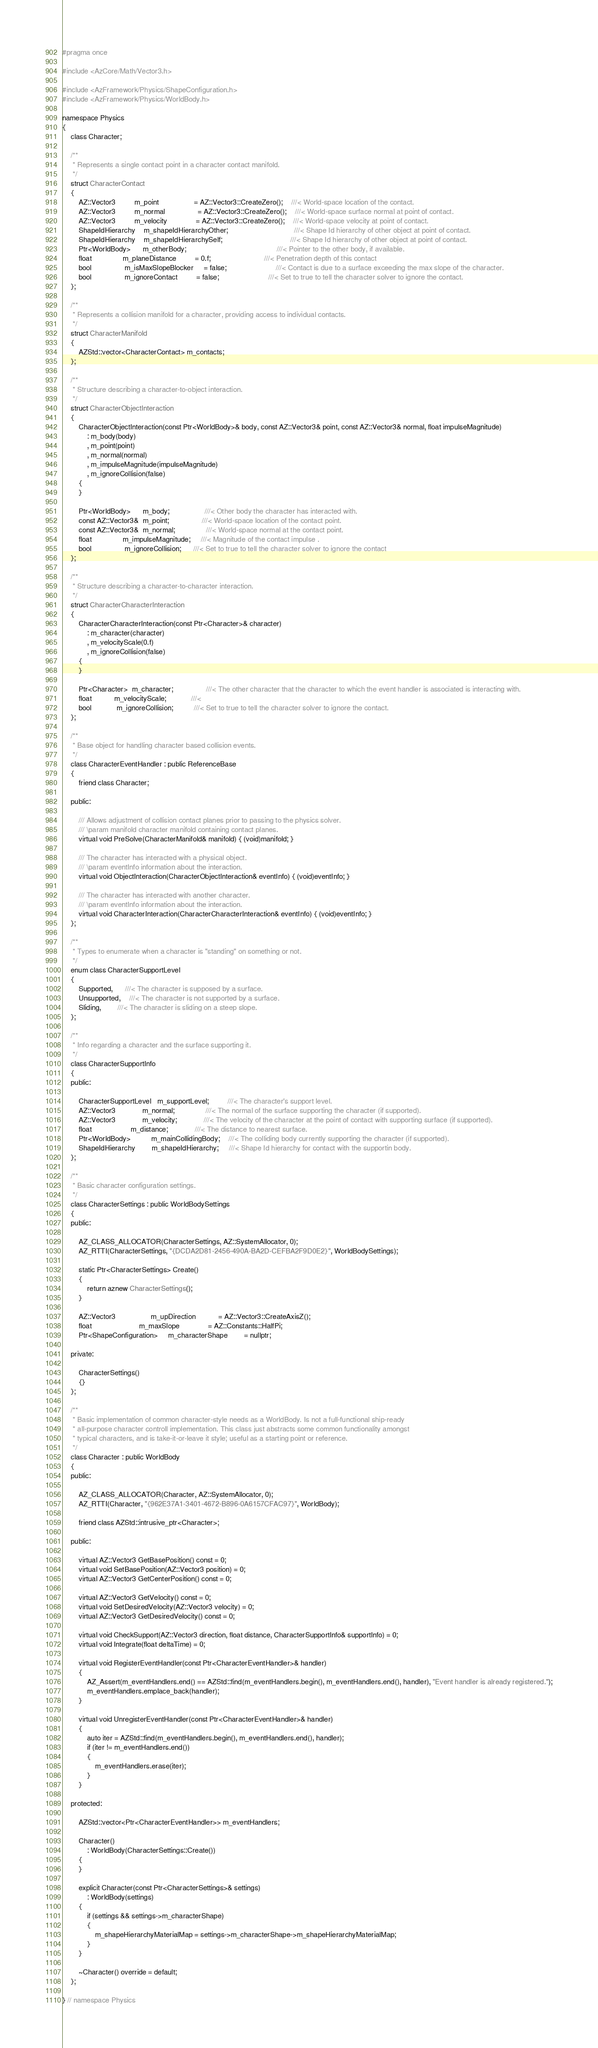<code> <loc_0><loc_0><loc_500><loc_500><_C_>
#pragma once

#include <AzCore/Math/Vector3.h>

#include <AzFramework/Physics/ShapeConfiguration.h>
#include <AzFramework/Physics/WorldBody.h>

namespace Physics
{
    class Character;

    /**
     * Represents a single contact point in a character contact manifold.
     */
    struct CharacterContact
    {
        AZ::Vector3         m_point                 = AZ::Vector3::CreateZero();    ///< World-space location of the contact.
        AZ::Vector3         m_normal                = AZ::Vector3::CreateZero();    ///< World-space surface normal at point of contact.
        AZ::Vector3         m_velocity              = AZ::Vector3::CreateZero();    ///< World-space velocity at point of contact.
        ShapeIdHierarchy    m_shapeIdHierarchyOther;                                ///< Shape Id hierarchy of other object at point of contact.
        ShapeIdHierarchy    m_shapeIdHierarchySelf;                                 ///< Shape Id hierarchy of other object at point of contact.
        Ptr<WorldBody>      m_otherBody;                                            ///< Pointer to the other body, if available.
        float               m_planeDistance         = 0.f;                          ///< Penetration depth of this contact
        bool                m_isMaxSlopeBlocker     = false;                        ///< Contact is due to a surface exceeding the max slope of the character.
        bool                m_ignoreContact         = false;                        ///< Set to true to tell the character solver to ignore the contact.
    };

    /**
     * Represents a collision manifold for a character, providing access to individual contacts.
     */
    struct CharacterManifold
    {
        AZStd::vector<CharacterContact> m_contacts;
    };

    /**
     * Structure describing a character-to-object interaction.
     */
    struct CharacterObjectInteraction
    {
        CharacterObjectInteraction(const Ptr<WorldBody>& body, const AZ::Vector3& point, const AZ::Vector3& normal, float impulseMagnitude)
            : m_body(body)
            , m_point(point)
            , m_normal(normal)
            , m_impulseMagnitude(impulseMagnitude)
            , m_ignoreCollision(false)
        {
        }

        Ptr<WorldBody>      m_body;                 ///< Other body the character has interacted with.
        const AZ::Vector3&  m_point;                ///< World-space location of the contact point.
        const AZ::Vector3&  m_normal;               ///< World-space normal at the contact point.
        float               m_impulseMagnitude;     ///< Magnitude of the contact impulse .
        bool                m_ignoreCollision;      ///< Set to true to tell the character solver to ignore the contact
    };

    /**
     * Structure describing a character-to-character interaction.
     */
    struct CharacterCharacterInteraction
    {
        CharacterCharacterInteraction(const Ptr<Character>& character)
            : m_character(character)
            , m_velocityScale(0.f)
            , m_ignoreCollision(false)
        {
        }

        Ptr<Character>  m_character;                ///< The other character that the character to which the event handler is associated is interacting with.
        float           m_velocityScale;            ///< 
        bool            m_ignoreCollision;          ///< Set to true to tell the character solver to ignore the contact.
    };

    /**
     * Base object for handling character based collision events.
     */
    class CharacterEventHandler : public ReferenceBase
    {
        friend class Character;

    public:

        /// Allows adjustment of collision contact planes prior to passing to the physics solver.
        /// \param manifold character manifold containing contact planes.
        virtual void PreSolve(CharacterManifold& manifold) { (void)manifold; }

        /// The character has interacted with a physical object.
        /// \param eventInfo information about the interaction.
        virtual void ObjectInteraction(CharacterObjectInteraction& eventInfo) { (void)eventInfo; }

        /// The character has interacted with another character.
        /// \param eventInfo information about the interaction.
        virtual void CharacterInteraction(CharacterCharacterInteraction& eventInfo) { (void)eventInfo; }
    };

    /**
     * Types to enumerate when a character is "standing" on something or not.
     */
    enum class CharacterSupportLevel
    {
        Supported,      ///< The character is supposed by a surface.
        Unsupported,    ///< The character is not supported by a surface.
        Sliding,        ///< The character is sliding on a steep slope.
    };

    /**
     * Info regarding a character and the surface supporting it.
     */
    class CharacterSupportInfo
    {
    public:

        CharacterSupportLevel   m_supportLevel;         ///< The character's support level.
        AZ::Vector3             m_normal;               ///< The normal of the surface supporting the character (if supported).
        AZ::Vector3             m_velocity;             ///< The velocity of the character at the point of contact with supporting surface (if supported).
        float                   m_distance;             ///< The distance to nearest surface.
        Ptr<WorldBody>          m_mainCollidingBody;    ///< The colliding body currently supporting the character (if supported).
        ShapeIdHierarchy        m_shapeIdHierarchy;     ///< Shape Id hierarchy for contact with the supportin body.
    };

    /**
     * Basic character configuration settings.
     */
    class CharacterSettings : public WorldBodySettings
    {
    public:

        AZ_CLASS_ALLOCATOR(CharacterSettings, AZ::SystemAllocator, 0);
        AZ_RTTI(CharacterSettings, "{DCDA2D81-2456-490A-BA2D-CEFBA2F9D0E2}", WorldBodySettings);

        static Ptr<CharacterSettings> Create()
        {
            return aznew CharacterSettings();
        }

        AZ::Vector3                 m_upDirection           = AZ::Vector3::CreateAxisZ();
        float                       m_maxSlope              = AZ::Constants::HalfPi;
        Ptr<ShapeConfiguration>     m_characterShape        = nullptr;

    private:

        CharacterSettings()
        {}
    };

    /**
     * Basic implementation of common character-style needs as a WorldBody. Is not a full-functional ship-ready
     * all-purpose character controll implementation. This class just abstracts some common functionality amongst
     * typical characters, and is take-it-or-leave it style; useful as a starting point or reference.
     */
    class Character : public WorldBody
    {
    public:

        AZ_CLASS_ALLOCATOR(Character, AZ::SystemAllocator, 0);
        AZ_RTTI(Character, "{962E37A1-3401-4672-B896-0A6157CFAC97}", WorldBody);

        friend class AZStd::intrusive_ptr<Character>;

    public:

        virtual AZ::Vector3 GetBasePosition() const = 0;
        virtual void SetBasePosition(AZ::Vector3 position) = 0;
        virtual AZ::Vector3 GetCenterPosition() const = 0;

        virtual AZ::Vector3 GetVelocity() const = 0;
        virtual void SetDesiredVelocity(AZ::Vector3 velocity) = 0;
        virtual AZ::Vector3 GetDesiredVelocity() const = 0;

        virtual void CheckSupport(AZ::Vector3 direction, float distance, CharacterSupportInfo& supportInfo) = 0;
        virtual void Integrate(float deltaTime) = 0;

        virtual void RegisterEventHandler(const Ptr<CharacterEventHandler>& handler)
        {
            AZ_Assert(m_eventHandlers.end() == AZStd::find(m_eventHandlers.begin(), m_eventHandlers.end(), handler), "Event handler is already registered.");
            m_eventHandlers.emplace_back(handler);
        }

        virtual void UnregisterEventHandler(const Ptr<CharacterEventHandler>& handler)
        {
            auto iter = AZStd::find(m_eventHandlers.begin(), m_eventHandlers.end(), handler);
            if (iter != m_eventHandlers.end())
            {
                m_eventHandlers.erase(iter);
            }
        }

    protected:

        AZStd::vector<Ptr<CharacterEventHandler>> m_eventHandlers;

        Character()
            : WorldBody(CharacterSettings::Create())
        {
        }

        explicit Character(const Ptr<CharacterSettings>& settings)
            : WorldBody(settings)
        {
            if (settings && settings->m_characterShape)
            {
                m_shapeHierarchyMaterialMap = settings->m_characterShape->m_shapeHierarchyMaterialMap;
            }
        }

        ~Character() override = default;
    };
    
} // namespace Physics
</code> 